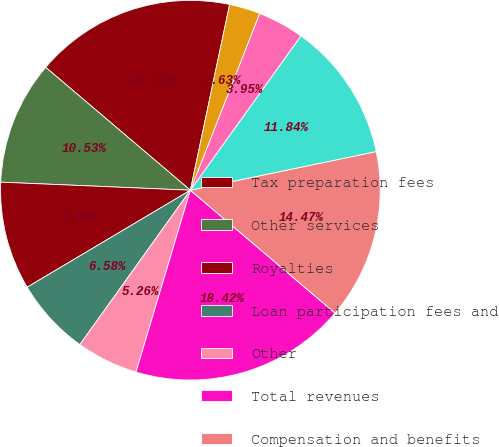<chart> <loc_0><loc_0><loc_500><loc_500><pie_chart><fcel>Tax preparation fees<fcel>Other services<fcel>Royalties<fcel>Loan participation fees and<fcel>Other<fcel>Total revenues<fcel>Compensation and benefits<fcel>Occupancy<fcel>Supplies<fcel>Bad debt<nl><fcel>17.11%<fcel>10.53%<fcel>9.21%<fcel>6.58%<fcel>5.26%<fcel>18.42%<fcel>14.47%<fcel>11.84%<fcel>3.95%<fcel>2.63%<nl></chart> 